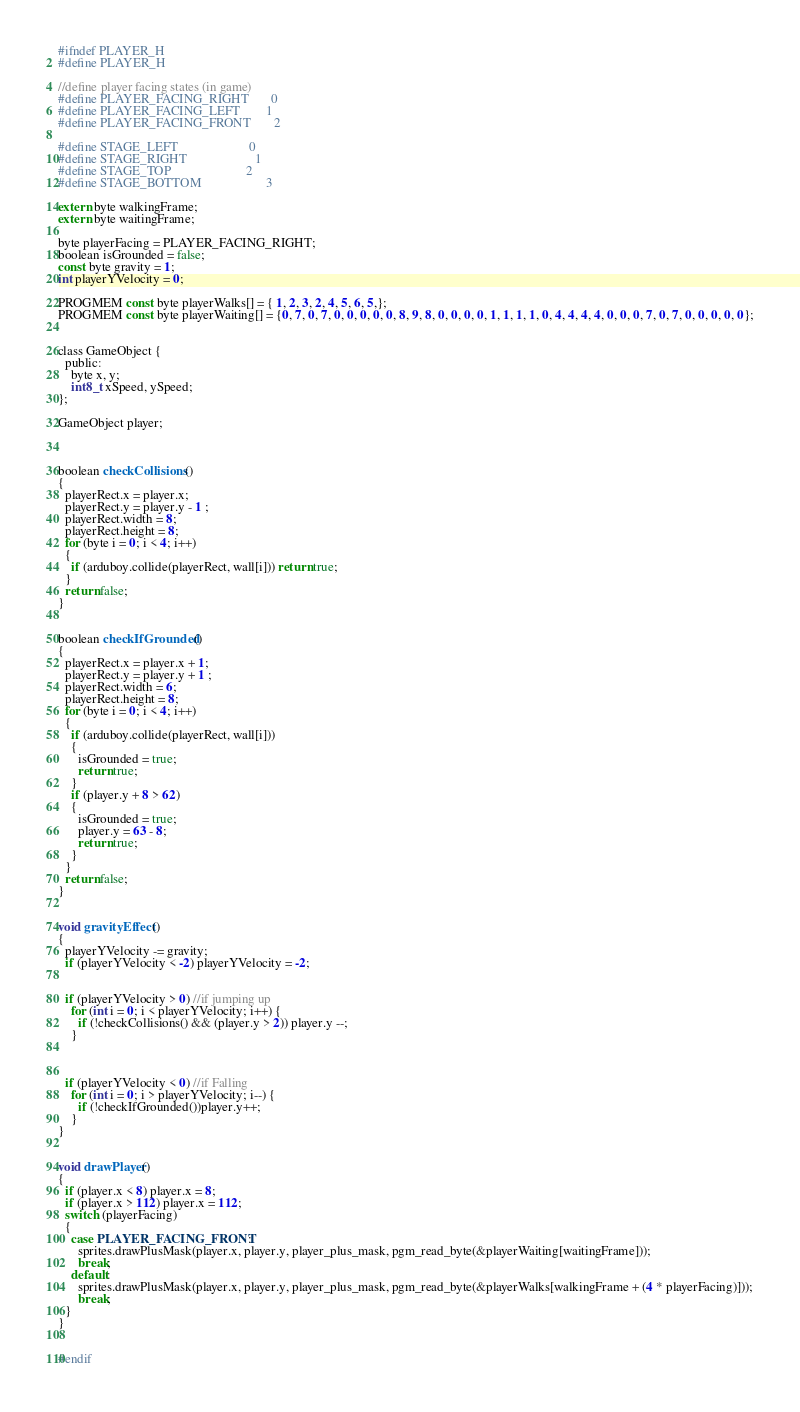<code> <loc_0><loc_0><loc_500><loc_500><_C_>#ifndef PLAYER_H
#define PLAYER_H

//define player facing states (in game)
#define PLAYER_FACING_RIGHT       0
#define PLAYER_FACING_LEFT        1
#define PLAYER_FACING_FRONT       2

#define STAGE_LEFT                      0
#define STAGE_RIGHT                     1
#define STAGE_TOP                       2
#define STAGE_BOTTOM                    3

extern byte walkingFrame;
extern byte waitingFrame;

byte playerFacing = PLAYER_FACING_RIGHT;
boolean isGrounded = false;
const byte gravity = 1;
int playerYVelocity = 0;

PROGMEM const byte playerWalks[] = { 1, 2, 3, 2, 4, 5, 6, 5,};
PROGMEM const byte playerWaiting[] = {0, 7, 0, 7, 0, 0, 0, 0, 0, 8, 9, 8, 0, 0, 0, 0, 1, 1, 1, 1, 0, 4, 4, 4, 4, 0, 0, 0, 7, 0, 7, 0, 0, 0, 0, 0};


class GameObject {
  public:
    byte x, y;
    int8_t xSpeed, ySpeed;
};

GameObject player;



boolean checkCollisions()
{
  playerRect.x = player.x;
  playerRect.y = player.y - 1 ;
  playerRect.width = 8;
  playerRect.height = 8;
  for (byte i = 0; i < 4; i++)
  {
    if (arduboy.collide(playerRect, wall[i])) return true;
  }
  return false;
}


boolean checkIfGrounded()
{
  playerRect.x = player.x + 1;
  playerRect.y = player.y + 1 ;
  playerRect.width = 6;
  playerRect.height = 8;
  for (byte i = 0; i < 4; i++)
  {
    if (arduboy.collide(playerRect, wall[i]))
    {
      isGrounded = true;
      return true;
    }
    if (player.y + 8 > 62)
    {
      isGrounded = true;
      player.y = 63 - 8;
      return true;
    }
  }
  return false;
}


void gravityEffect()
{
  playerYVelocity -= gravity;
  if (playerYVelocity < -2) playerYVelocity = -2;


  if (playerYVelocity > 0) //if jumping up
    for (int i = 0; i < playerYVelocity; i++) {
      if (!checkCollisions() && (player.y > 2)) player.y --;
    }



  if (playerYVelocity < 0) //if Falling
    for (int i = 0; i > playerYVelocity; i--) {
      if (!checkIfGrounded())player.y++;
    }
}


void drawPlayer()
{
  if (player.x < 8) player.x = 8;
  if (player.x > 112) player.x = 112;
  switch (playerFacing)
  {
    case PLAYER_FACING_FRONT:
      sprites.drawPlusMask(player.x, player.y, player_plus_mask, pgm_read_byte(&playerWaiting[waitingFrame]));
      break;
    default:
      sprites.drawPlusMask(player.x, player.y, player_plus_mask, pgm_read_byte(&playerWalks[walkingFrame + (4 * playerFacing)]));
      break;
  }
}


#endif
</code> 